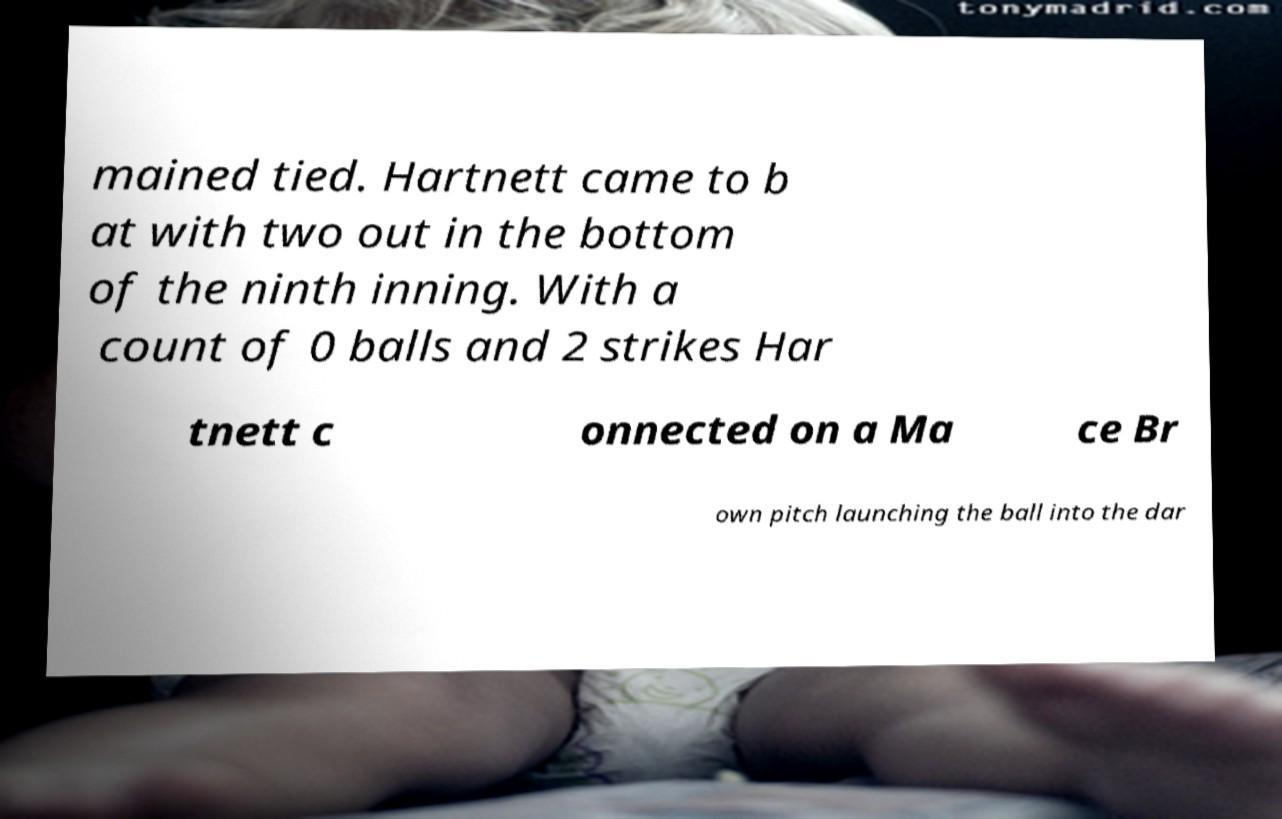Could you extract and type out the text from this image? mained tied. Hartnett came to b at with two out in the bottom of the ninth inning. With a count of 0 balls and 2 strikes Har tnett c onnected on a Ma ce Br own pitch launching the ball into the dar 